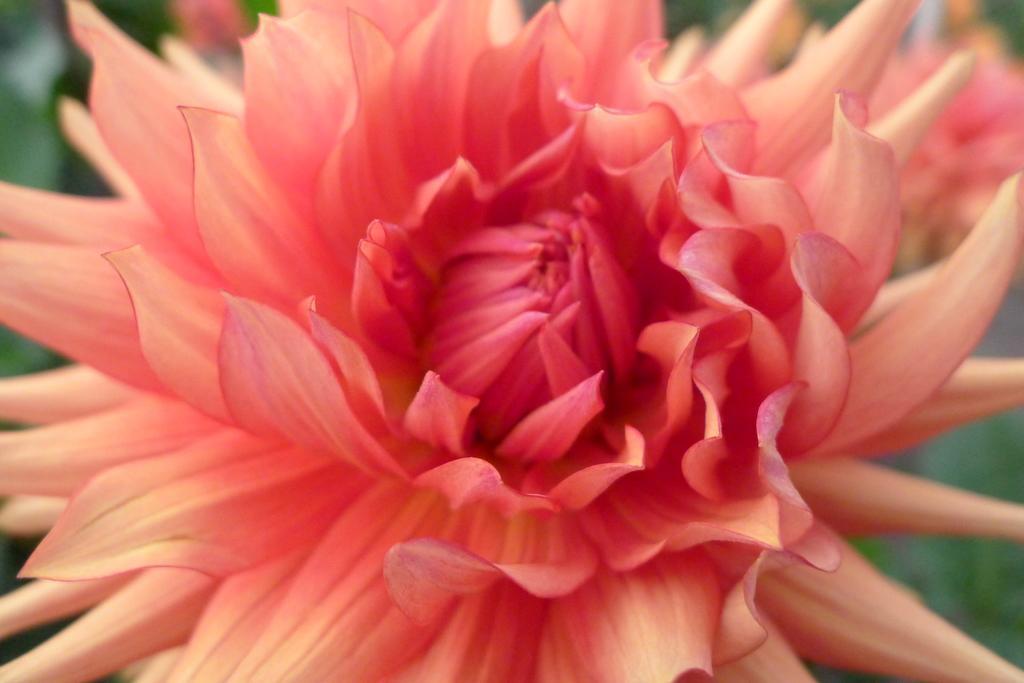How would you summarize this image in a sentence or two? In the image we can see a flower. Background of the image is blur. 